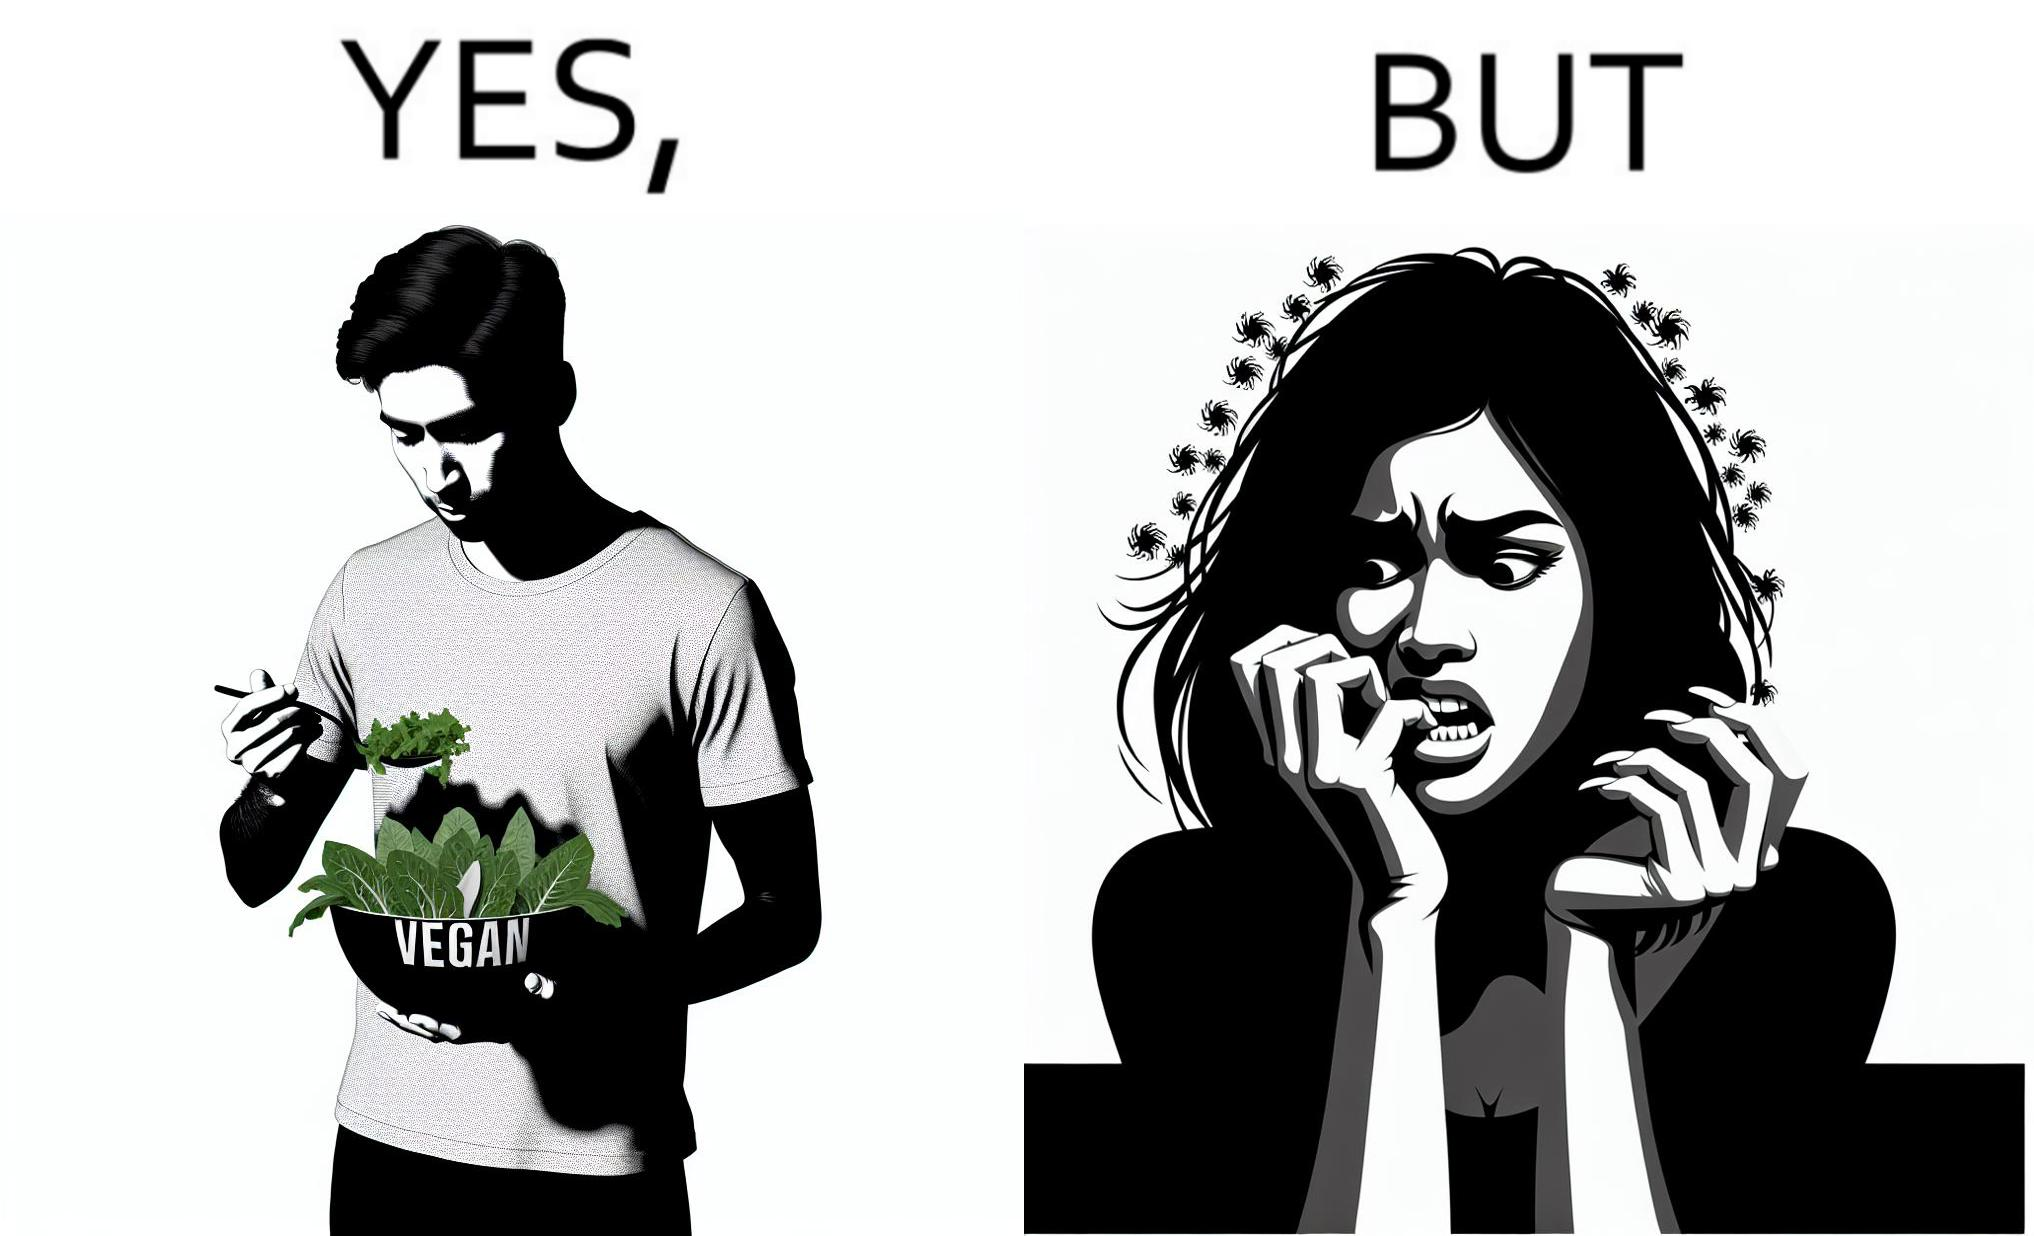Is this image satirical or non-satirical? Yes, this image is satirical. 